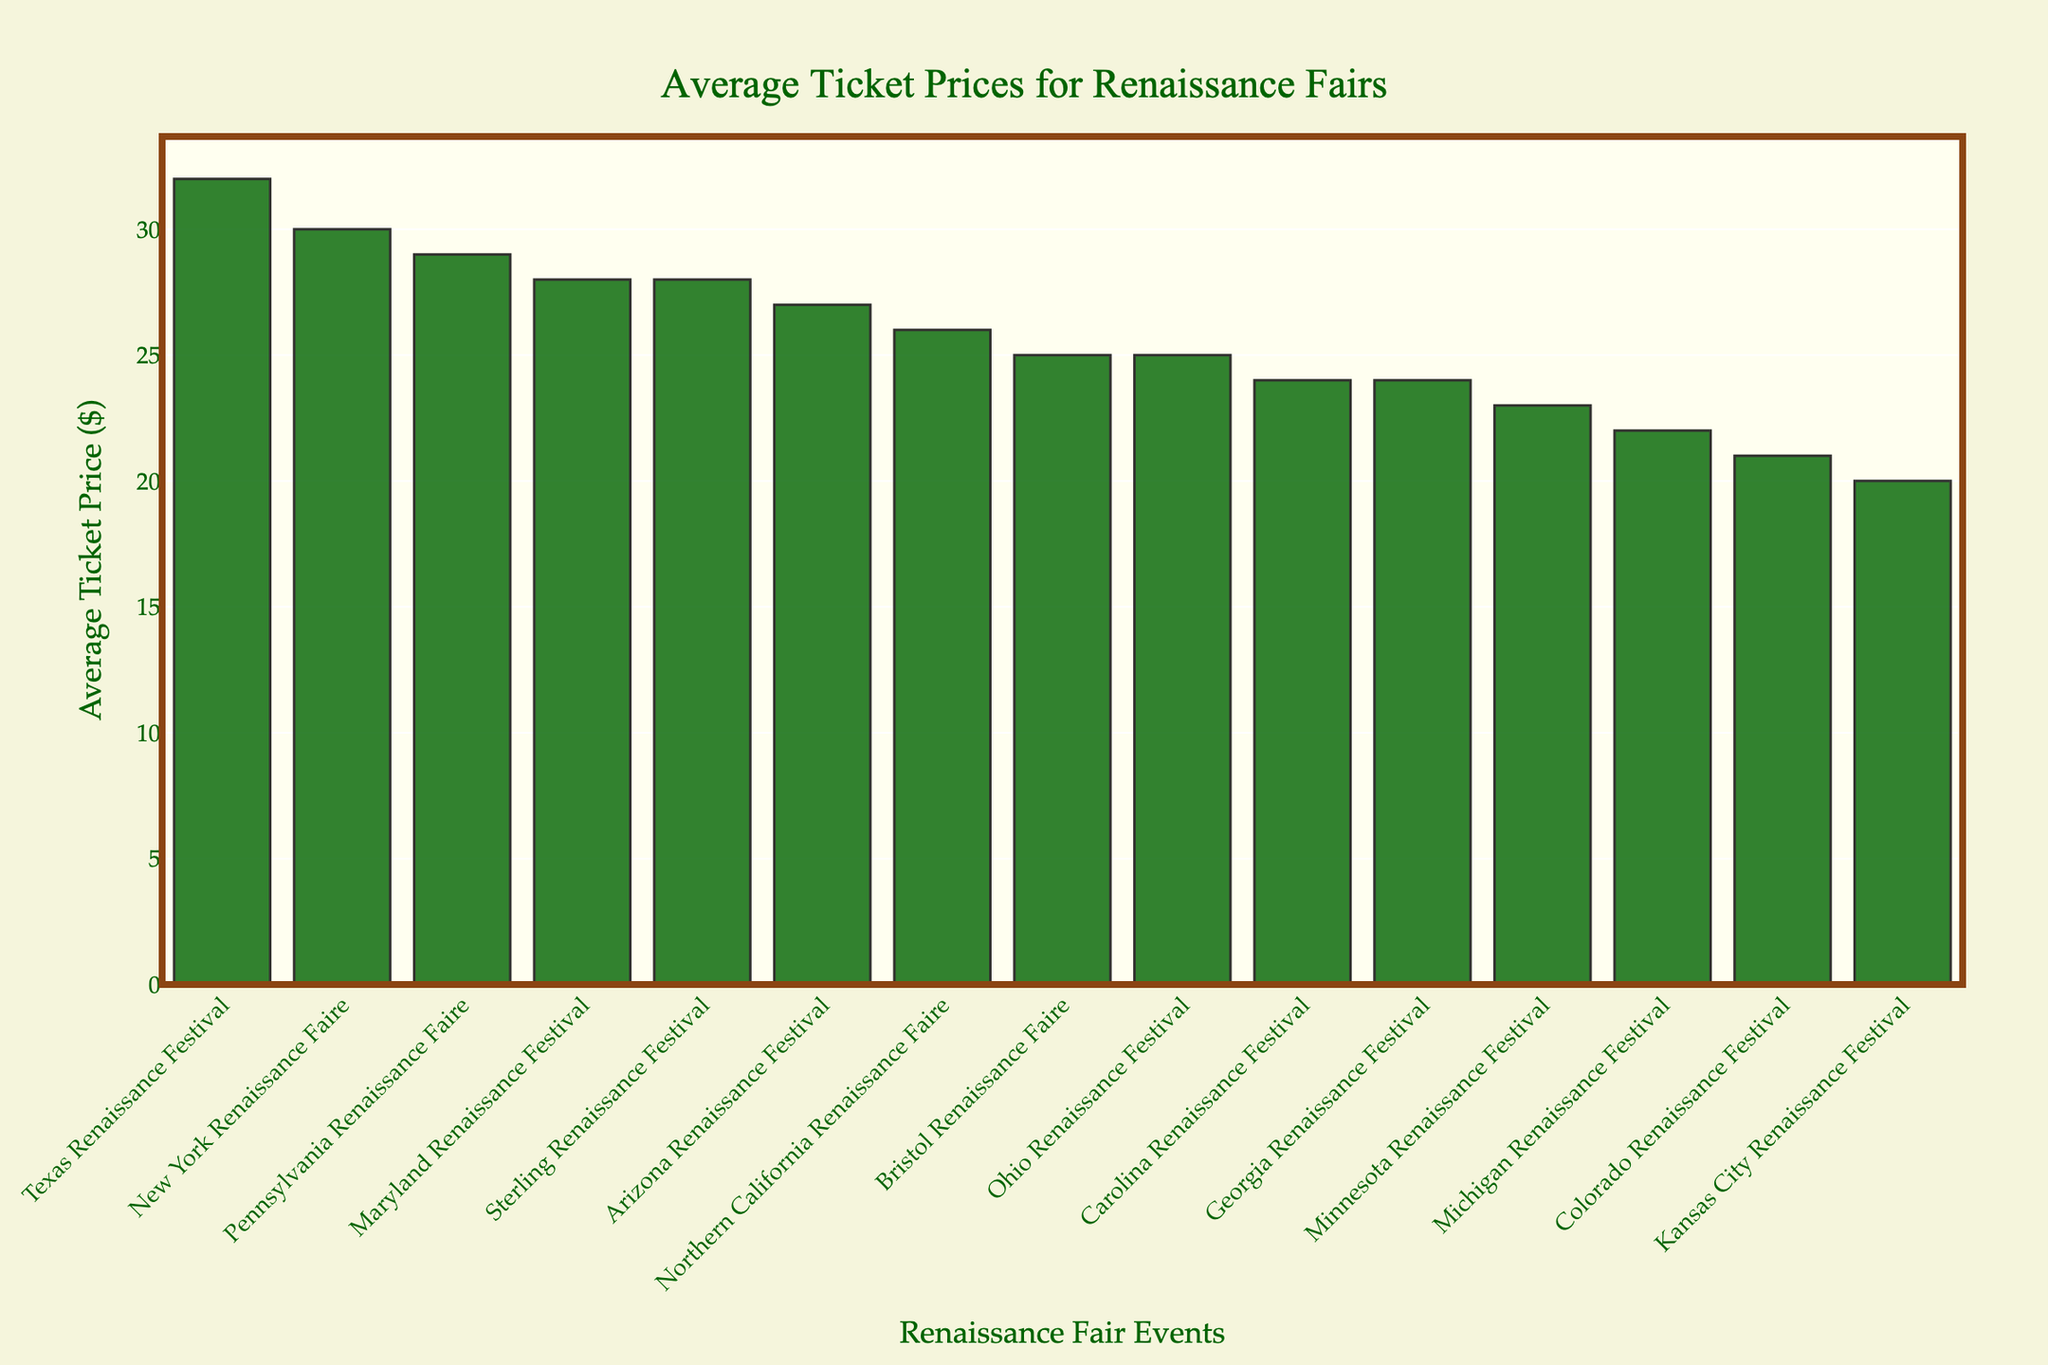Which event has the highest average ticket price? By looking at the heights of the bars, the Texas Renaissance Festival has the tallest bar, indicating it has the highest average ticket price.
Answer: Texas Renaissance Festival Which event has the lowest average ticket price? The Kansas City Renaissance Festival has the shortest bar among all the events, indicating it has the lowest average ticket price.
Answer: Kansas City Renaissance Festival What is the difference in average ticket price between the Texas Renaissance Festival and the Kansas City Renaissance Festival? The average ticket price for the Texas Renaissance Festival is $32, and for the Kansas City Renaissance Festival, it's $20. The difference is $32 - $20 = $12.
Answer: $12 How many events have an average ticket price greater than $25? By visually scanning the bars, the events that have a bar height above $25 are the Texas Renaissance Festival, Maryland Renaissance Festival, New York Renaissance Faire, Pennsylvania Renaissance Faire, Arizona Renaissance Festival, and Sterling Renaissance Festival. Counting these gives 6 events.
Answer: 6 What's the combined average ticket price of the Maryland and Minnesota Renaissance Festivals? The average ticket price for the Maryland Renaissance Festival is $28 and for the Minnesota Renaissance Festival, it's $23. Their combined average ticket price is $28 + $23 = $51.
Answer: $51 Which event has a higher average ticket price: the Michigan Renaissance Festival or the Colorado Renaissance Festival? By comparing the two bars, the Michigan Renaissance Festival has an average ticket price of $22, while the Colorado Renaissance Festival has an average ticket price of $21. Hence, the Michigan Renaissance Festival has a higher average ticket price.
Answer: Michigan Renaissance Festival Which events have a similar average ticket price ($28)? The events with bars reaching $28 are the Maryland Renaissance Festival and the Sterling Renaissance Festival.
Answer: Maryland Renaissance Festival, Sterling Renaissance Festival What is the range of average ticket prices across all events? The highest average ticket price is for the Texas Renaissance Festival at $32, and the lowest is for the Kansas City Renaissance Festival at $20. The range is $32 - $20 = $12.
Answer: $12 What is the median average ticket price of these events? To find the median, list all average ticket prices in ascending order: 20, 21, 22, 23, 24, 24, 25, 25, 26, 27, 28, 28, 29, 30, 32. The middle value (8th value) is 25.
Answer: $25 